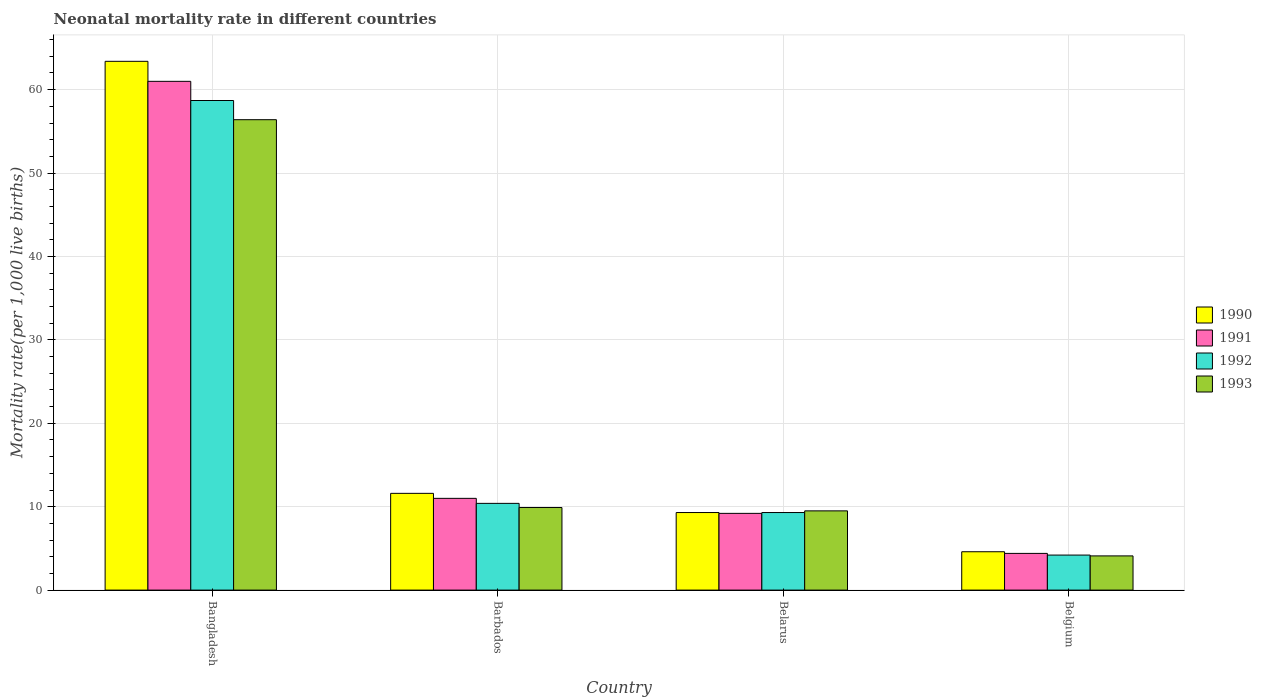Are the number of bars per tick equal to the number of legend labels?
Your response must be concise. Yes. What is the label of the 3rd group of bars from the left?
Provide a succinct answer. Belarus. In how many cases, is the number of bars for a given country not equal to the number of legend labels?
Your response must be concise. 0. What is the neonatal mortality rate in 1990 in Bangladesh?
Provide a short and direct response. 63.4. What is the total neonatal mortality rate in 1993 in the graph?
Keep it short and to the point. 79.9. What is the difference between the neonatal mortality rate in 1990 in Belarus and that in Belgium?
Make the answer very short. 4.7. What is the difference between the neonatal mortality rate in 1992 in Belgium and the neonatal mortality rate in 1990 in Bangladesh?
Your answer should be very brief. -59.2. What is the average neonatal mortality rate in 1990 per country?
Your response must be concise. 22.22. What is the difference between the neonatal mortality rate of/in 1992 and neonatal mortality rate of/in 1990 in Bangladesh?
Ensure brevity in your answer.  -4.7. In how many countries, is the neonatal mortality rate in 1992 greater than 48?
Provide a succinct answer. 1. What is the ratio of the neonatal mortality rate in 1991 in Bangladesh to that in Belgium?
Your answer should be very brief. 13.86. Is the neonatal mortality rate in 1992 in Belarus less than that in Belgium?
Make the answer very short. No. Is the difference between the neonatal mortality rate in 1992 in Bangladesh and Belgium greater than the difference between the neonatal mortality rate in 1990 in Bangladesh and Belgium?
Offer a very short reply. No. What is the difference between the highest and the second highest neonatal mortality rate in 1991?
Offer a terse response. -1.8. What is the difference between the highest and the lowest neonatal mortality rate in 1993?
Give a very brief answer. 52.3. Is the sum of the neonatal mortality rate in 1992 in Barbados and Belgium greater than the maximum neonatal mortality rate in 1990 across all countries?
Offer a terse response. No. What does the 1st bar from the left in Barbados represents?
Your response must be concise. 1990. Is it the case that in every country, the sum of the neonatal mortality rate in 1993 and neonatal mortality rate in 1990 is greater than the neonatal mortality rate in 1992?
Offer a terse response. Yes. Are all the bars in the graph horizontal?
Keep it short and to the point. No. Does the graph contain any zero values?
Keep it short and to the point. No. How many legend labels are there?
Make the answer very short. 4. What is the title of the graph?
Make the answer very short. Neonatal mortality rate in different countries. What is the label or title of the Y-axis?
Offer a terse response. Mortality rate(per 1,0 live births). What is the Mortality rate(per 1,000 live births) in 1990 in Bangladesh?
Keep it short and to the point. 63.4. What is the Mortality rate(per 1,000 live births) of 1992 in Bangladesh?
Ensure brevity in your answer.  58.7. What is the Mortality rate(per 1,000 live births) in 1993 in Bangladesh?
Offer a terse response. 56.4. What is the Mortality rate(per 1,000 live births) in 1990 in Belarus?
Provide a succinct answer. 9.3. What is the Mortality rate(per 1,000 live births) in 1991 in Belarus?
Provide a succinct answer. 9.2. What is the Mortality rate(per 1,000 live births) in 1992 in Belgium?
Your answer should be very brief. 4.2. Across all countries, what is the maximum Mortality rate(per 1,000 live births) of 1990?
Your response must be concise. 63.4. Across all countries, what is the maximum Mortality rate(per 1,000 live births) of 1992?
Provide a short and direct response. 58.7. Across all countries, what is the maximum Mortality rate(per 1,000 live births) of 1993?
Make the answer very short. 56.4. Across all countries, what is the minimum Mortality rate(per 1,000 live births) of 1990?
Ensure brevity in your answer.  4.6. Across all countries, what is the minimum Mortality rate(per 1,000 live births) in 1992?
Ensure brevity in your answer.  4.2. What is the total Mortality rate(per 1,000 live births) in 1990 in the graph?
Your response must be concise. 88.9. What is the total Mortality rate(per 1,000 live births) in 1991 in the graph?
Provide a succinct answer. 85.6. What is the total Mortality rate(per 1,000 live births) in 1992 in the graph?
Keep it short and to the point. 82.6. What is the total Mortality rate(per 1,000 live births) of 1993 in the graph?
Your answer should be compact. 79.9. What is the difference between the Mortality rate(per 1,000 live births) in 1990 in Bangladesh and that in Barbados?
Provide a short and direct response. 51.8. What is the difference between the Mortality rate(per 1,000 live births) in 1991 in Bangladesh and that in Barbados?
Provide a short and direct response. 50. What is the difference between the Mortality rate(per 1,000 live births) in 1992 in Bangladesh and that in Barbados?
Provide a succinct answer. 48.3. What is the difference between the Mortality rate(per 1,000 live births) of 1993 in Bangladesh and that in Barbados?
Make the answer very short. 46.5. What is the difference between the Mortality rate(per 1,000 live births) in 1990 in Bangladesh and that in Belarus?
Make the answer very short. 54.1. What is the difference between the Mortality rate(per 1,000 live births) of 1991 in Bangladesh and that in Belarus?
Make the answer very short. 51.8. What is the difference between the Mortality rate(per 1,000 live births) in 1992 in Bangladesh and that in Belarus?
Give a very brief answer. 49.4. What is the difference between the Mortality rate(per 1,000 live births) of 1993 in Bangladesh and that in Belarus?
Make the answer very short. 46.9. What is the difference between the Mortality rate(per 1,000 live births) in 1990 in Bangladesh and that in Belgium?
Give a very brief answer. 58.8. What is the difference between the Mortality rate(per 1,000 live births) of 1991 in Bangladesh and that in Belgium?
Your response must be concise. 56.6. What is the difference between the Mortality rate(per 1,000 live births) in 1992 in Bangladesh and that in Belgium?
Keep it short and to the point. 54.5. What is the difference between the Mortality rate(per 1,000 live births) of 1993 in Bangladesh and that in Belgium?
Offer a terse response. 52.3. What is the difference between the Mortality rate(per 1,000 live births) of 1990 in Barbados and that in Belarus?
Provide a succinct answer. 2.3. What is the difference between the Mortality rate(per 1,000 live births) in 1991 in Barbados and that in Belarus?
Your answer should be very brief. 1.8. What is the difference between the Mortality rate(per 1,000 live births) of 1992 in Barbados and that in Belarus?
Ensure brevity in your answer.  1.1. What is the difference between the Mortality rate(per 1,000 live births) of 1990 in Barbados and that in Belgium?
Ensure brevity in your answer.  7. What is the difference between the Mortality rate(per 1,000 live births) in 1993 in Barbados and that in Belgium?
Provide a succinct answer. 5.8. What is the difference between the Mortality rate(per 1,000 live births) of 1990 in Belarus and that in Belgium?
Give a very brief answer. 4.7. What is the difference between the Mortality rate(per 1,000 live births) of 1991 in Belarus and that in Belgium?
Your answer should be compact. 4.8. What is the difference between the Mortality rate(per 1,000 live births) of 1993 in Belarus and that in Belgium?
Provide a succinct answer. 5.4. What is the difference between the Mortality rate(per 1,000 live births) in 1990 in Bangladesh and the Mortality rate(per 1,000 live births) in 1991 in Barbados?
Make the answer very short. 52.4. What is the difference between the Mortality rate(per 1,000 live births) of 1990 in Bangladesh and the Mortality rate(per 1,000 live births) of 1992 in Barbados?
Provide a short and direct response. 53. What is the difference between the Mortality rate(per 1,000 live births) in 1990 in Bangladesh and the Mortality rate(per 1,000 live births) in 1993 in Barbados?
Ensure brevity in your answer.  53.5. What is the difference between the Mortality rate(per 1,000 live births) in 1991 in Bangladesh and the Mortality rate(per 1,000 live births) in 1992 in Barbados?
Keep it short and to the point. 50.6. What is the difference between the Mortality rate(per 1,000 live births) of 1991 in Bangladesh and the Mortality rate(per 1,000 live births) of 1993 in Barbados?
Offer a terse response. 51.1. What is the difference between the Mortality rate(per 1,000 live births) of 1992 in Bangladesh and the Mortality rate(per 1,000 live births) of 1993 in Barbados?
Your response must be concise. 48.8. What is the difference between the Mortality rate(per 1,000 live births) of 1990 in Bangladesh and the Mortality rate(per 1,000 live births) of 1991 in Belarus?
Offer a terse response. 54.2. What is the difference between the Mortality rate(per 1,000 live births) of 1990 in Bangladesh and the Mortality rate(per 1,000 live births) of 1992 in Belarus?
Make the answer very short. 54.1. What is the difference between the Mortality rate(per 1,000 live births) in 1990 in Bangladesh and the Mortality rate(per 1,000 live births) in 1993 in Belarus?
Provide a succinct answer. 53.9. What is the difference between the Mortality rate(per 1,000 live births) in 1991 in Bangladesh and the Mortality rate(per 1,000 live births) in 1992 in Belarus?
Make the answer very short. 51.7. What is the difference between the Mortality rate(per 1,000 live births) of 1991 in Bangladesh and the Mortality rate(per 1,000 live births) of 1993 in Belarus?
Offer a very short reply. 51.5. What is the difference between the Mortality rate(per 1,000 live births) in 1992 in Bangladesh and the Mortality rate(per 1,000 live births) in 1993 in Belarus?
Give a very brief answer. 49.2. What is the difference between the Mortality rate(per 1,000 live births) of 1990 in Bangladesh and the Mortality rate(per 1,000 live births) of 1992 in Belgium?
Your response must be concise. 59.2. What is the difference between the Mortality rate(per 1,000 live births) of 1990 in Bangladesh and the Mortality rate(per 1,000 live births) of 1993 in Belgium?
Make the answer very short. 59.3. What is the difference between the Mortality rate(per 1,000 live births) of 1991 in Bangladesh and the Mortality rate(per 1,000 live births) of 1992 in Belgium?
Keep it short and to the point. 56.8. What is the difference between the Mortality rate(per 1,000 live births) in 1991 in Bangladesh and the Mortality rate(per 1,000 live births) in 1993 in Belgium?
Your answer should be compact. 56.9. What is the difference between the Mortality rate(per 1,000 live births) in 1992 in Bangladesh and the Mortality rate(per 1,000 live births) in 1993 in Belgium?
Your answer should be very brief. 54.6. What is the difference between the Mortality rate(per 1,000 live births) of 1990 in Barbados and the Mortality rate(per 1,000 live births) of 1991 in Belarus?
Provide a short and direct response. 2.4. What is the difference between the Mortality rate(per 1,000 live births) of 1990 in Barbados and the Mortality rate(per 1,000 live births) of 1992 in Belarus?
Your answer should be compact. 2.3. What is the difference between the Mortality rate(per 1,000 live births) in 1990 in Barbados and the Mortality rate(per 1,000 live births) in 1993 in Belarus?
Your answer should be compact. 2.1. What is the difference between the Mortality rate(per 1,000 live births) in 1991 in Barbados and the Mortality rate(per 1,000 live births) in 1993 in Belarus?
Make the answer very short. 1.5. What is the difference between the Mortality rate(per 1,000 live births) in 1990 in Barbados and the Mortality rate(per 1,000 live births) in 1991 in Belgium?
Make the answer very short. 7.2. What is the difference between the Mortality rate(per 1,000 live births) in 1990 in Belarus and the Mortality rate(per 1,000 live births) in 1991 in Belgium?
Provide a succinct answer. 4.9. What is the difference between the Mortality rate(per 1,000 live births) in 1990 in Belarus and the Mortality rate(per 1,000 live births) in 1992 in Belgium?
Give a very brief answer. 5.1. What is the difference between the Mortality rate(per 1,000 live births) in 1991 in Belarus and the Mortality rate(per 1,000 live births) in 1993 in Belgium?
Provide a succinct answer. 5.1. What is the average Mortality rate(per 1,000 live births) of 1990 per country?
Offer a terse response. 22.23. What is the average Mortality rate(per 1,000 live births) of 1991 per country?
Ensure brevity in your answer.  21.4. What is the average Mortality rate(per 1,000 live births) in 1992 per country?
Give a very brief answer. 20.65. What is the average Mortality rate(per 1,000 live births) in 1993 per country?
Offer a terse response. 19.98. What is the difference between the Mortality rate(per 1,000 live births) of 1990 and Mortality rate(per 1,000 live births) of 1991 in Bangladesh?
Provide a short and direct response. 2.4. What is the difference between the Mortality rate(per 1,000 live births) of 1990 and Mortality rate(per 1,000 live births) of 1992 in Bangladesh?
Offer a very short reply. 4.7. What is the difference between the Mortality rate(per 1,000 live births) in 1991 and Mortality rate(per 1,000 live births) in 1993 in Bangladesh?
Your answer should be compact. 4.6. What is the difference between the Mortality rate(per 1,000 live births) of 1990 and Mortality rate(per 1,000 live births) of 1991 in Barbados?
Offer a very short reply. 0.6. What is the difference between the Mortality rate(per 1,000 live births) of 1990 and Mortality rate(per 1,000 live births) of 1993 in Barbados?
Offer a terse response. 1.7. What is the difference between the Mortality rate(per 1,000 live births) in 1991 and Mortality rate(per 1,000 live births) in 1993 in Barbados?
Give a very brief answer. 1.1. What is the difference between the Mortality rate(per 1,000 live births) of 1992 and Mortality rate(per 1,000 live births) of 1993 in Barbados?
Provide a short and direct response. 0.5. What is the difference between the Mortality rate(per 1,000 live births) in 1990 and Mortality rate(per 1,000 live births) in 1992 in Belarus?
Keep it short and to the point. 0. What is the difference between the Mortality rate(per 1,000 live births) in 1990 and Mortality rate(per 1,000 live births) in 1993 in Belarus?
Ensure brevity in your answer.  -0.2. What is the difference between the Mortality rate(per 1,000 live births) in 1991 and Mortality rate(per 1,000 live births) in 1992 in Belarus?
Ensure brevity in your answer.  -0.1. What is the difference between the Mortality rate(per 1,000 live births) in 1991 and Mortality rate(per 1,000 live births) in 1993 in Belarus?
Your answer should be very brief. -0.3. What is the difference between the Mortality rate(per 1,000 live births) of 1990 and Mortality rate(per 1,000 live births) of 1991 in Belgium?
Provide a succinct answer. 0.2. What is the difference between the Mortality rate(per 1,000 live births) in 1990 and Mortality rate(per 1,000 live births) in 1992 in Belgium?
Your response must be concise. 0.4. What is the difference between the Mortality rate(per 1,000 live births) of 1990 and Mortality rate(per 1,000 live births) of 1993 in Belgium?
Offer a very short reply. 0.5. What is the difference between the Mortality rate(per 1,000 live births) of 1992 and Mortality rate(per 1,000 live births) of 1993 in Belgium?
Provide a short and direct response. 0.1. What is the ratio of the Mortality rate(per 1,000 live births) in 1990 in Bangladesh to that in Barbados?
Ensure brevity in your answer.  5.47. What is the ratio of the Mortality rate(per 1,000 live births) in 1991 in Bangladesh to that in Barbados?
Give a very brief answer. 5.55. What is the ratio of the Mortality rate(per 1,000 live births) of 1992 in Bangladesh to that in Barbados?
Provide a short and direct response. 5.64. What is the ratio of the Mortality rate(per 1,000 live births) in 1993 in Bangladesh to that in Barbados?
Keep it short and to the point. 5.7. What is the ratio of the Mortality rate(per 1,000 live births) in 1990 in Bangladesh to that in Belarus?
Offer a terse response. 6.82. What is the ratio of the Mortality rate(per 1,000 live births) of 1991 in Bangladesh to that in Belarus?
Offer a very short reply. 6.63. What is the ratio of the Mortality rate(per 1,000 live births) of 1992 in Bangladesh to that in Belarus?
Offer a terse response. 6.31. What is the ratio of the Mortality rate(per 1,000 live births) of 1993 in Bangladesh to that in Belarus?
Your response must be concise. 5.94. What is the ratio of the Mortality rate(per 1,000 live births) of 1990 in Bangladesh to that in Belgium?
Ensure brevity in your answer.  13.78. What is the ratio of the Mortality rate(per 1,000 live births) in 1991 in Bangladesh to that in Belgium?
Give a very brief answer. 13.86. What is the ratio of the Mortality rate(per 1,000 live births) of 1992 in Bangladesh to that in Belgium?
Provide a short and direct response. 13.98. What is the ratio of the Mortality rate(per 1,000 live births) in 1993 in Bangladesh to that in Belgium?
Your response must be concise. 13.76. What is the ratio of the Mortality rate(per 1,000 live births) of 1990 in Barbados to that in Belarus?
Your response must be concise. 1.25. What is the ratio of the Mortality rate(per 1,000 live births) of 1991 in Barbados to that in Belarus?
Give a very brief answer. 1.2. What is the ratio of the Mortality rate(per 1,000 live births) in 1992 in Barbados to that in Belarus?
Keep it short and to the point. 1.12. What is the ratio of the Mortality rate(per 1,000 live births) in 1993 in Barbados to that in Belarus?
Give a very brief answer. 1.04. What is the ratio of the Mortality rate(per 1,000 live births) in 1990 in Barbados to that in Belgium?
Give a very brief answer. 2.52. What is the ratio of the Mortality rate(per 1,000 live births) of 1992 in Barbados to that in Belgium?
Offer a terse response. 2.48. What is the ratio of the Mortality rate(per 1,000 live births) in 1993 in Barbados to that in Belgium?
Your answer should be very brief. 2.41. What is the ratio of the Mortality rate(per 1,000 live births) in 1990 in Belarus to that in Belgium?
Your response must be concise. 2.02. What is the ratio of the Mortality rate(per 1,000 live births) of 1991 in Belarus to that in Belgium?
Your answer should be very brief. 2.09. What is the ratio of the Mortality rate(per 1,000 live births) of 1992 in Belarus to that in Belgium?
Provide a short and direct response. 2.21. What is the ratio of the Mortality rate(per 1,000 live births) of 1993 in Belarus to that in Belgium?
Keep it short and to the point. 2.32. What is the difference between the highest and the second highest Mortality rate(per 1,000 live births) of 1990?
Your response must be concise. 51.8. What is the difference between the highest and the second highest Mortality rate(per 1,000 live births) of 1992?
Ensure brevity in your answer.  48.3. What is the difference between the highest and the second highest Mortality rate(per 1,000 live births) of 1993?
Provide a short and direct response. 46.5. What is the difference between the highest and the lowest Mortality rate(per 1,000 live births) of 1990?
Provide a succinct answer. 58.8. What is the difference between the highest and the lowest Mortality rate(per 1,000 live births) in 1991?
Keep it short and to the point. 56.6. What is the difference between the highest and the lowest Mortality rate(per 1,000 live births) of 1992?
Offer a very short reply. 54.5. What is the difference between the highest and the lowest Mortality rate(per 1,000 live births) in 1993?
Your answer should be very brief. 52.3. 